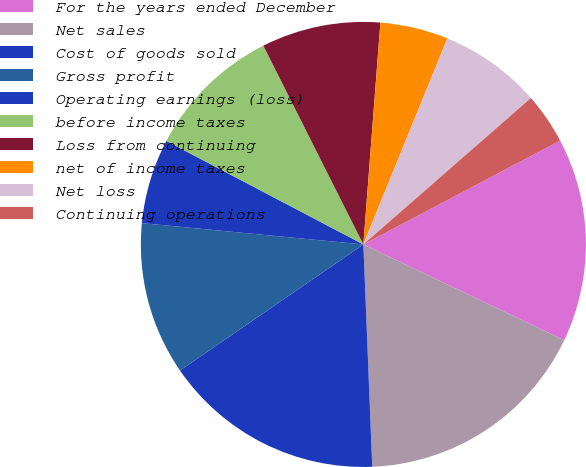<chart> <loc_0><loc_0><loc_500><loc_500><pie_chart><fcel>For the years ended December<fcel>Net sales<fcel>Cost of goods sold<fcel>Gross profit<fcel>Operating earnings (loss)<fcel>before income taxes<fcel>Loss from continuing<fcel>net of income taxes<fcel>Net loss<fcel>Continuing operations<nl><fcel>14.81%<fcel>17.28%<fcel>16.05%<fcel>11.11%<fcel>6.17%<fcel>9.88%<fcel>8.64%<fcel>4.94%<fcel>7.41%<fcel>3.7%<nl></chart> 